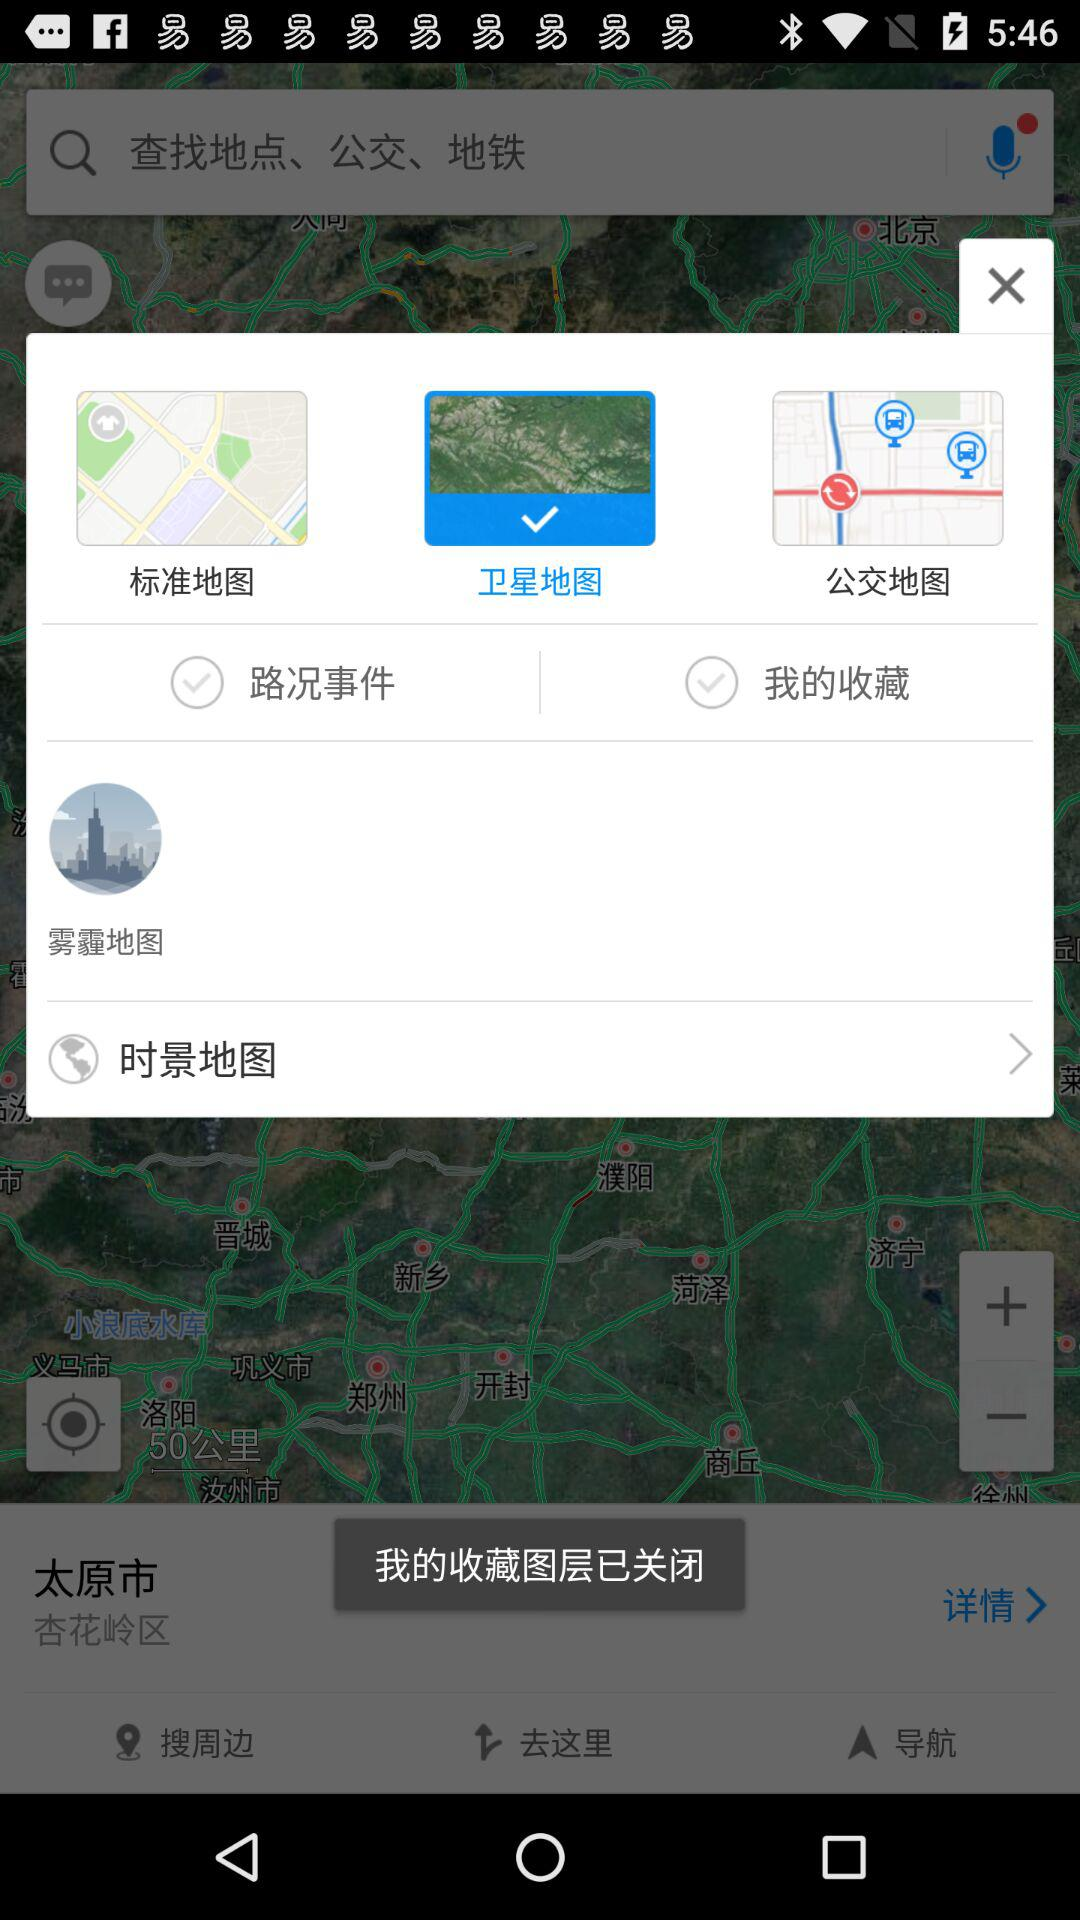How many check boxes are there on the map screen?
Answer the question using a single word or phrase. 2 